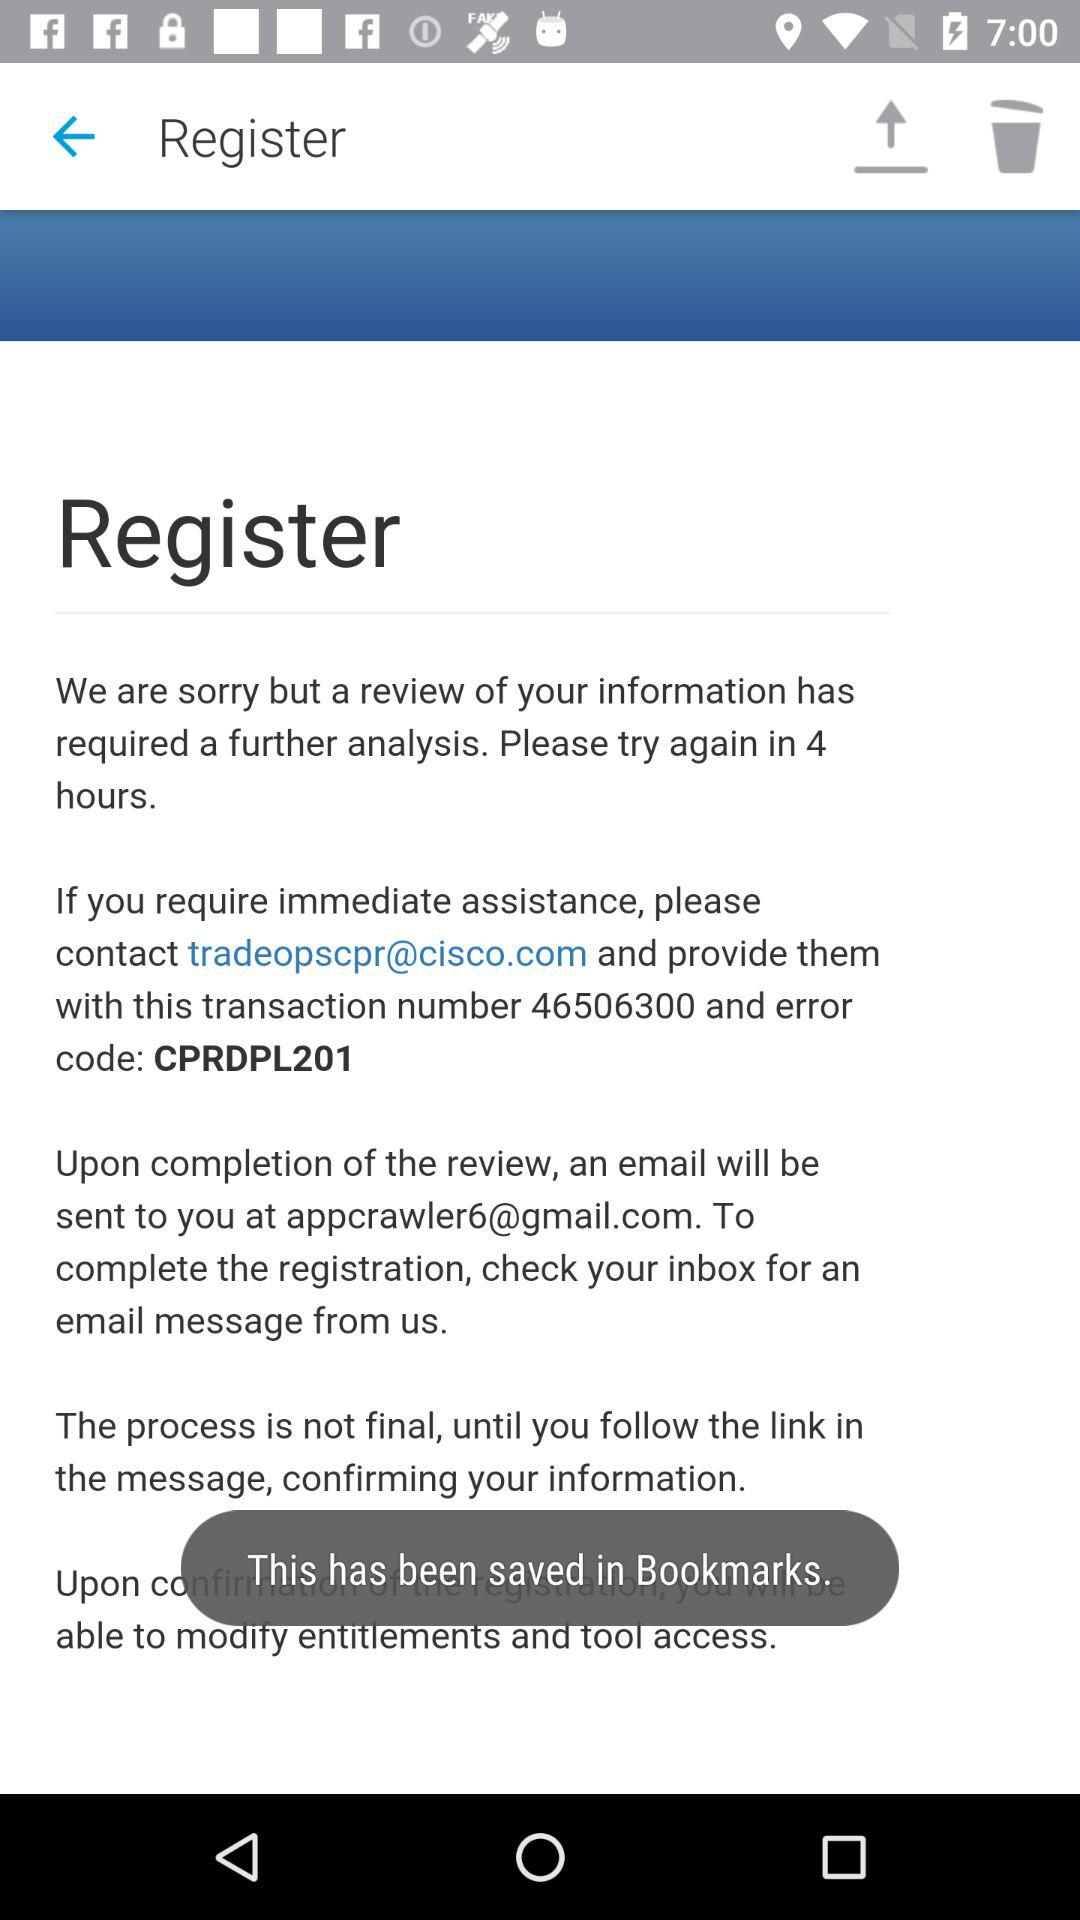What is the email address of the user? The email address is appcrawler6@gmail.com. 